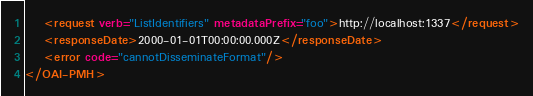Convert code to text. <code><loc_0><loc_0><loc_500><loc_500><_XML_>	<request verb="ListIdentifiers" metadataPrefix="foo">http://localhost:1337</request>
	<responseDate>2000-01-01T00:00:00.000Z</responseDate>
	<error code="cannotDisseminateFormat"/>
</OAI-PMH></code> 